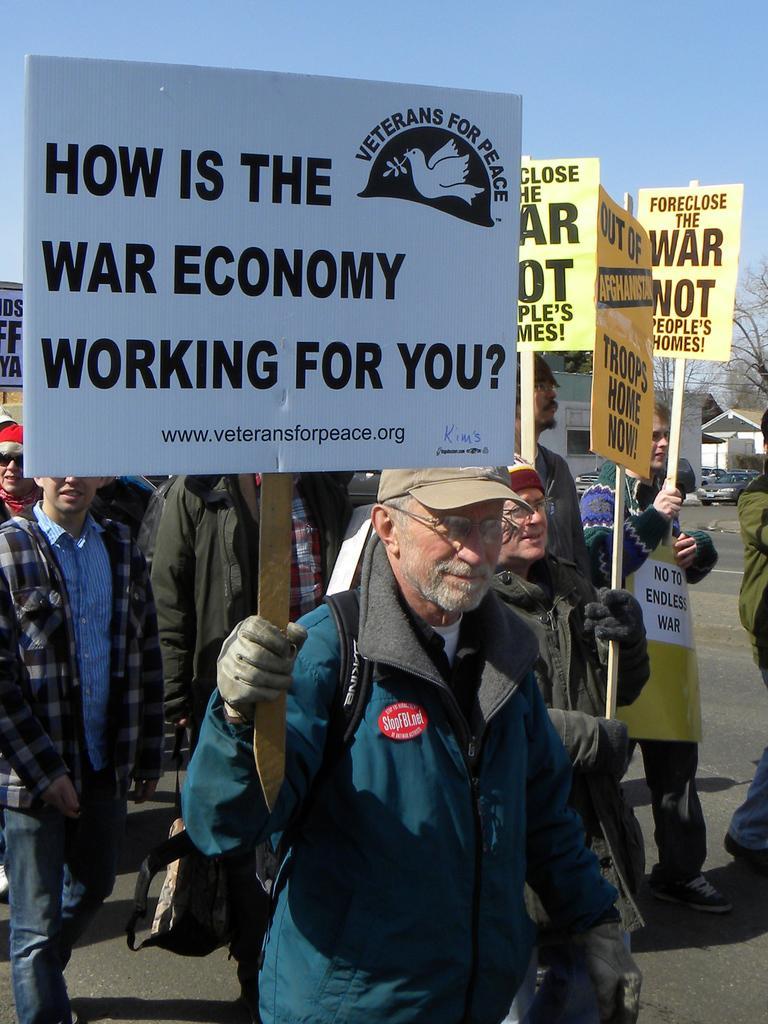Can you describe this image briefly? In this image we can see the people walking on the road and holding the boards with text and logo. And at the back we can see the houses, vehicles, trees and sky in the background. 